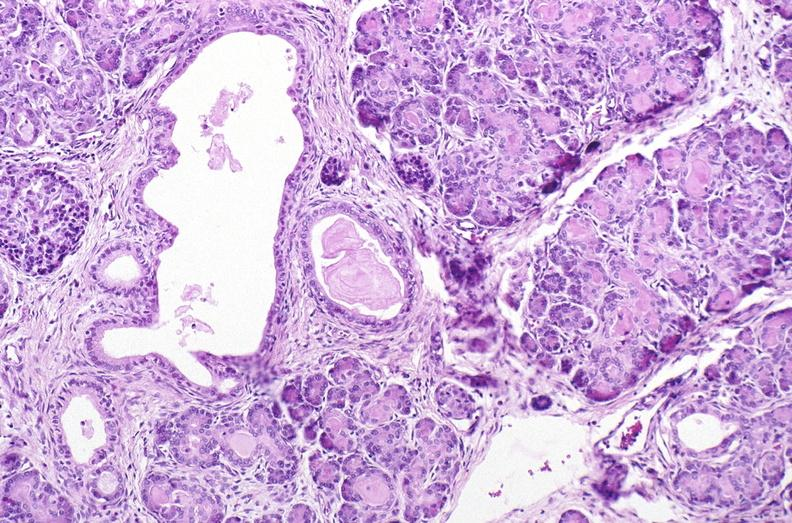does this image show cystic fibrosis?
Answer the question using a single word or phrase. Yes 